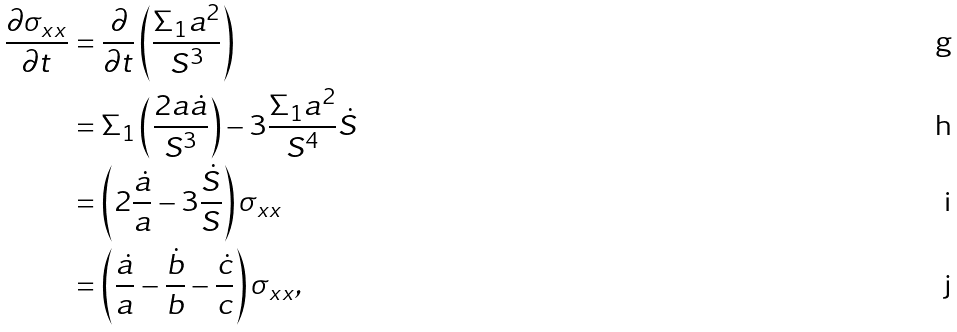Convert formula to latex. <formula><loc_0><loc_0><loc_500><loc_500>\frac { \partial \sigma _ { x x } } { \partial t } & = \frac { \partial } { \partial t } \left ( \frac { \Sigma _ { 1 } a ^ { 2 } } { S ^ { 3 } } \right ) \\ & = \Sigma _ { 1 } \left ( \frac { 2 a \dot { a } } { S ^ { 3 } } \right ) - 3 \frac { \Sigma _ { 1 } a ^ { 2 } } { S ^ { 4 } } \dot { S } \\ & = \left ( 2 \frac { \dot { a } } { a } - 3 \frac { \dot { S } } { S } \right ) \sigma _ { x x } \\ & = \left ( \frac { \dot { a } } { a } - \frac { \dot { b } } { b } - \frac { \dot { c } } { c } \right ) \sigma _ { x x } ,</formula> 